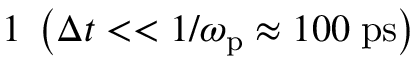<formula> <loc_0><loc_0><loc_500><loc_500>1 \, \left ( \Delta t < < 1 / \omega _ { p } \approx 1 0 0 \, p s \right )</formula> 